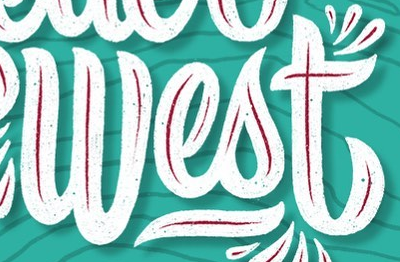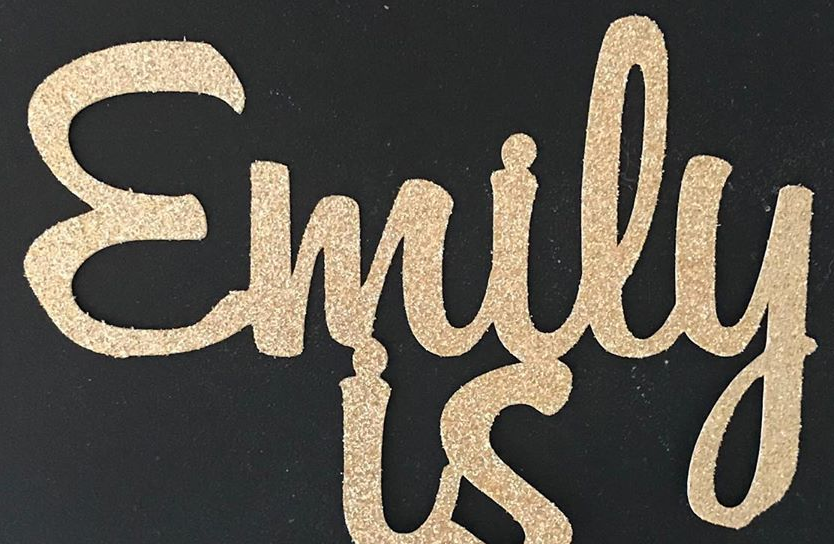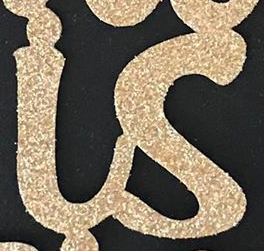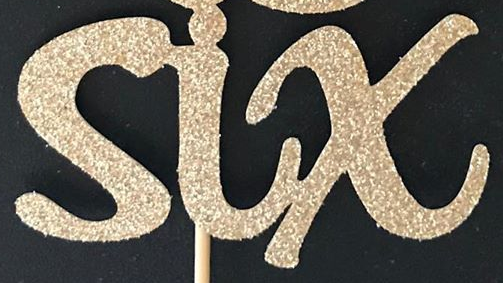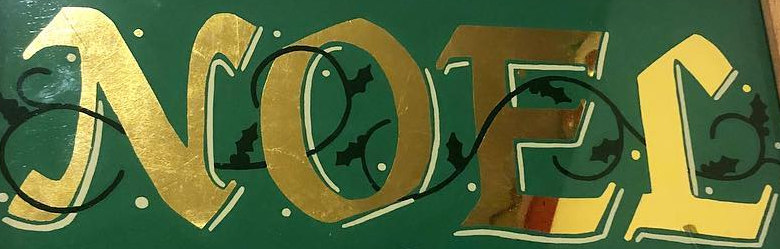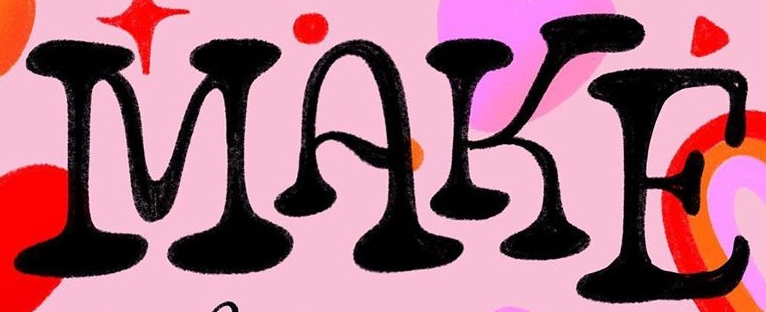Read the text content from these images in order, separated by a semicolon. West; Emily; is; six; NOEL; MAKE 